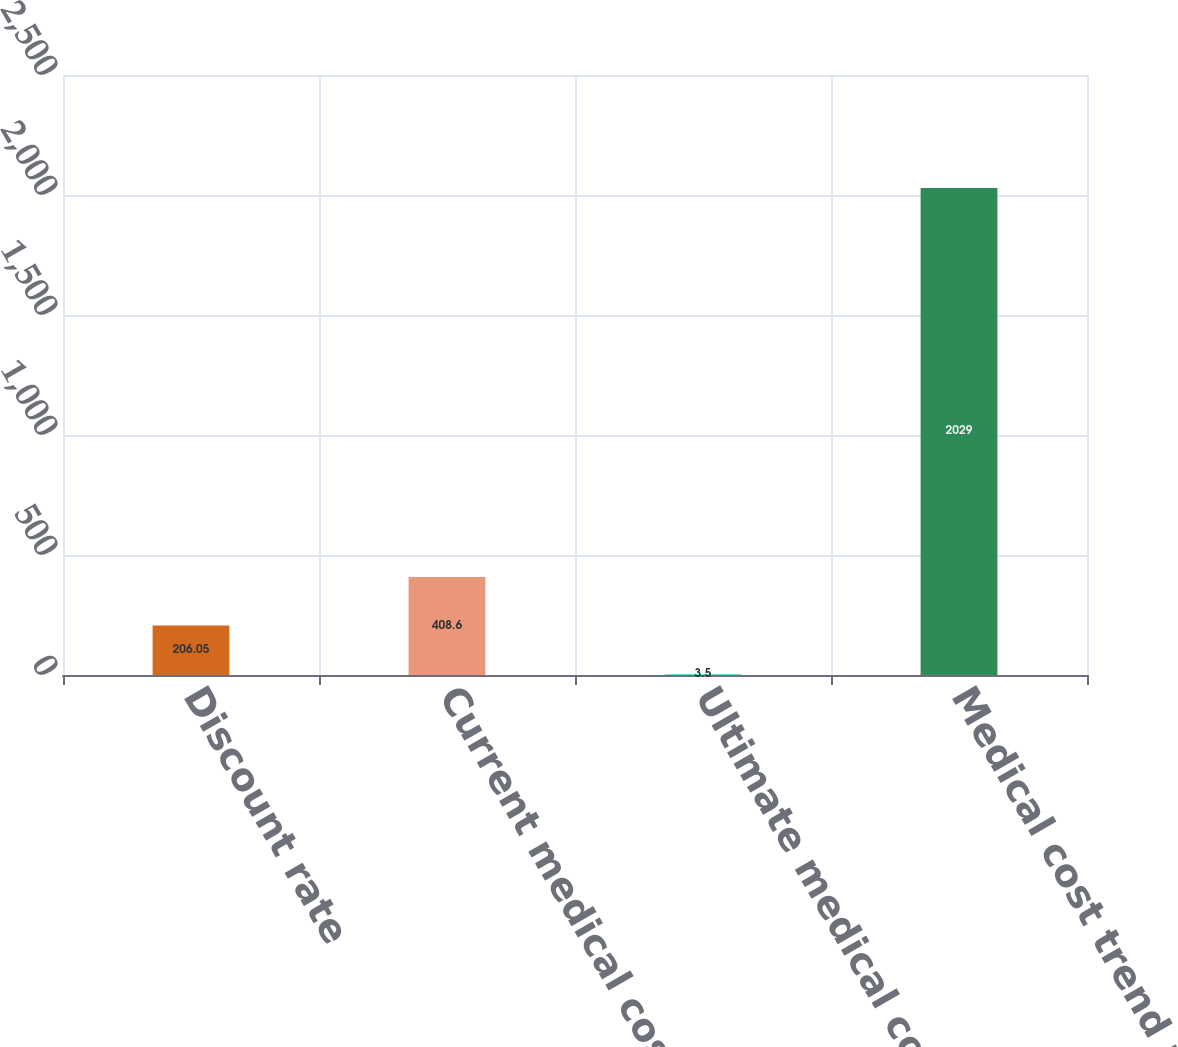<chart> <loc_0><loc_0><loc_500><loc_500><bar_chart><fcel>Discount rate<fcel>Current medical cost trend<fcel>Ultimate medical cost trend<fcel>Medical cost trend rate<nl><fcel>206.05<fcel>408.6<fcel>3.5<fcel>2029<nl></chart> 